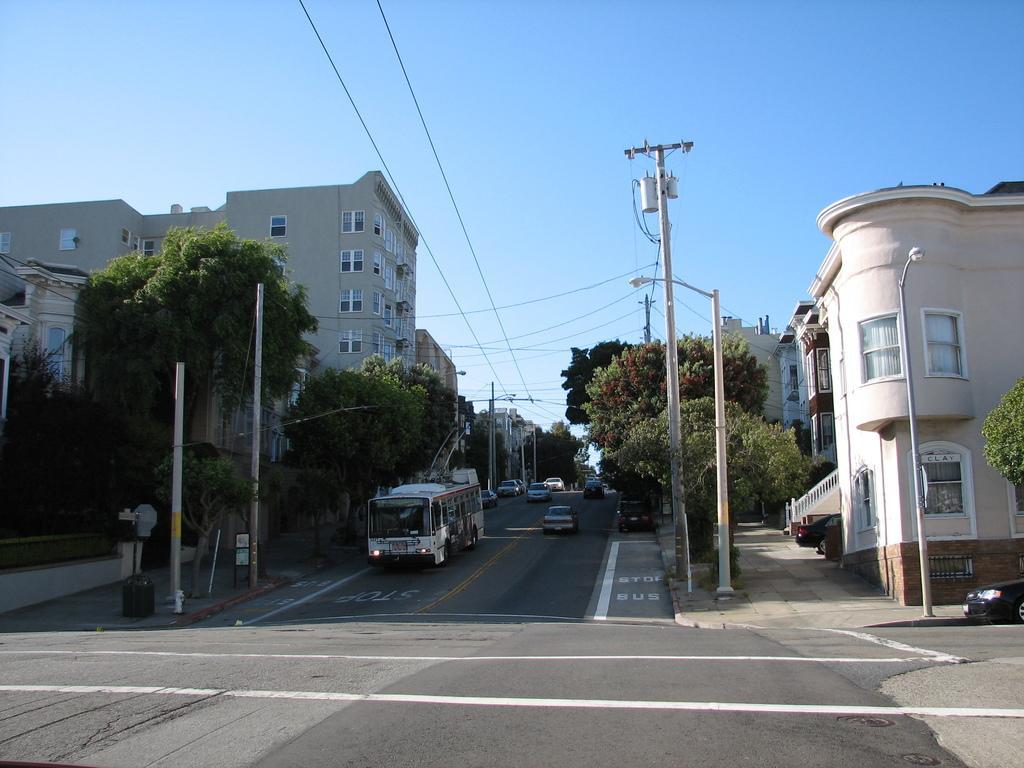In one or two sentences, can you explain what this image depicts? In this picture there is a bus on the road, beside that we can see many cars. On the left we can see the building, poles and street lights. On the right there is an electric pole and the wires are connected to it. Beside that we can see stairs. At the top there is a sky. At the bottom there is a road. In the bottom left corner there is a dustbin near to the wall. 